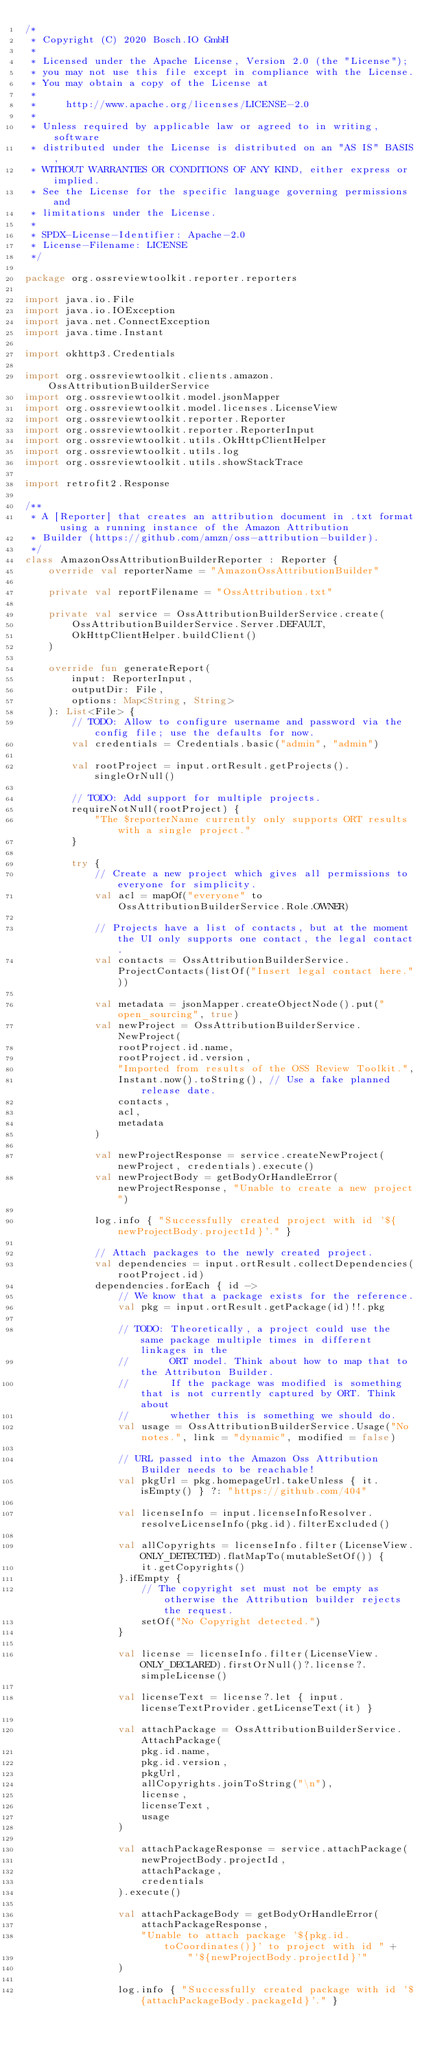<code> <loc_0><loc_0><loc_500><loc_500><_Kotlin_>/*
 * Copyright (C) 2020 Bosch.IO GmbH
 *
 * Licensed under the Apache License, Version 2.0 (the "License");
 * you may not use this file except in compliance with the License.
 * You may obtain a copy of the License at
 *
 *     http://www.apache.org/licenses/LICENSE-2.0
 *
 * Unless required by applicable law or agreed to in writing, software
 * distributed under the License is distributed on an "AS IS" BASIS,
 * WITHOUT WARRANTIES OR CONDITIONS OF ANY KIND, either express or implied.
 * See the License for the specific language governing permissions and
 * limitations under the License.
 *
 * SPDX-License-Identifier: Apache-2.0
 * License-Filename: LICENSE
 */

package org.ossreviewtoolkit.reporter.reporters

import java.io.File
import java.io.IOException
import java.net.ConnectException
import java.time.Instant

import okhttp3.Credentials

import org.ossreviewtoolkit.clients.amazon.OssAttributionBuilderService
import org.ossreviewtoolkit.model.jsonMapper
import org.ossreviewtoolkit.model.licenses.LicenseView
import org.ossreviewtoolkit.reporter.Reporter
import org.ossreviewtoolkit.reporter.ReporterInput
import org.ossreviewtoolkit.utils.OkHttpClientHelper
import org.ossreviewtoolkit.utils.log
import org.ossreviewtoolkit.utils.showStackTrace

import retrofit2.Response

/**
 * A [Reporter] that creates an attribution document in .txt format using a running instance of the Amazon Attribution
 * Builder (https://github.com/amzn/oss-attribution-builder).
 */
class AmazonOssAttributionBuilderReporter : Reporter {
    override val reporterName = "AmazonOssAttributionBuilder"

    private val reportFilename = "OssAttribution.txt"

    private val service = OssAttributionBuilderService.create(
        OssAttributionBuilderService.Server.DEFAULT,
        OkHttpClientHelper.buildClient()
    )

    override fun generateReport(
        input: ReporterInput,
        outputDir: File,
        options: Map<String, String>
    ): List<File> {
        // TODO: Allow to configure username and password via the config file; use the defaults for now.
        val credentials = Credentials.basic("admin", "admin")

        val rootProject = input.ortResult.getProjects().singleOrNull()

        // TODO: Add support for multiple projects.
        requireNotNull(rootProject) {
            "The $reporterName currently only supports ORT results with a single project."
        }

        try {
            // Create a new project which gives all permissions to everyone for simplicity.
            val acl = mapOf("everyone" to OssAttributionBuilderService.Role.OWNER)

            // Projects have a list of contacts, but at the moment the UI only supports one contact, the legal contact.
            val contacts = OssAttributionBuilderService.ProjectContacts(listOf("Insert legal contact here."))

            val metadata = jsonMapper.createObjectNode().put("open_sourcing", true)
            val newProject = OssAttributionBuilderService.NewProject(
                rootProject.id.name,
                rootProject.id.version,
                "Imported from results of the OSS Review Toolkit.",
                Instant.now().toString(), // Use a fake planned release date.
                contacts,
                acl,
                metadata
            )

            val newProjectResponse = service.createNewProject(newProject, credentials).execute()
            val newProjectBody = getBodyOrHandleError(newProjectResponse, "Unable to create a new project")

            log.info { "Successfully created project with id '${newProjectBody.projectId}'." }

            // Attach packages to the newly created project.
            val dependencies = input.ortResult.collectDependencies(rootProject.id)
            dependencies.forEach { id ->
                // We know that a package exists for the reference.
                val pkg = input.ortResult.getPackage(id)!!.pkg

                // TODO: Theoretically, a project could use the same package multiple times in different linkages in the
                //       ORT model. Think about how to map that to the Attributon Builder.
                //       If the package was modified is something that is not currently captured by ORT. Think about
                //       whether this is something we should do.
                val usage = OssAttributionBuilderService.Usage("No notes.", link = "dynamic", modified = false)

                // URL passed into the Amazon Oss Attribution Builder needs to be reachable!
                val pkgUrl = pkg.homepageUrl.takeUnless { it.isEmpty() } ?: "https://github.com/404"

                val licenseInfo = input.licenseInfoResolver.resolveLicenseInfo(pkg.id).filterExcluded()

                val allCopyrights = licenseInfo.filter(LicenseView.ONLY_DETECTED).flatMapTo(mutableSetOf()) {
                    it.getCopyrights()
                }.ifEmpty {
                    // The copyright set must not be empty as otherwise the Attribution builder rejects the request.
                    setOf("No Copyright detected.")
                }

                val license = licenseInfo.filter(LicenseView.ONLY_DECLARED).firstOrNull()?.license?.simpleLicense()

                val licenseText = license?.let { input.licenseTextProvider.getLicenseText(it) }

                val attachPackage = OssAttributionBuilderService.AttachPackage(
                    pkg.id.name,
                    pkg.id.version,
                    pkgUrl,
                    allCopyrights.joinToString("\n"),
                    license,
                    licenseText,
                    usage
                )

                val attachPackageResponse = service.attachPackage(
                    newProjectBody.projectId,
                    attachPackage,
                    credentials
                ).execute()

                val attachPackageBody = getBodyOrHandleError(
                    attachPackageResponse,
                    "Unable to attach package '${pkg.id.toCoordinates()}' to project with id " +
                            "'${newProjectBody.projectId}'"
                )

                log.info { "Successfully created package with id '${attachPackageBody.packageId}'." }</code> 